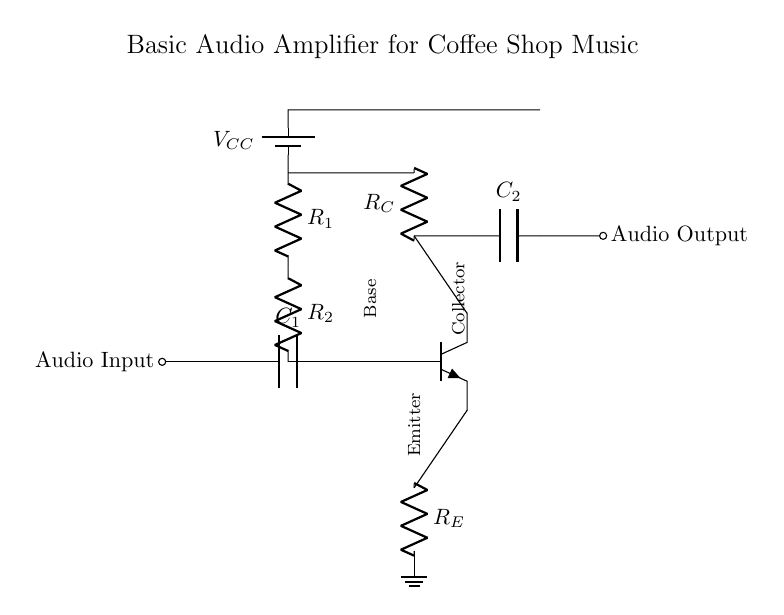What component is used to block DC voltage? The capacitor labeled C1 is used to block DC voltage while allowing AC signals to pass through. Capacitors in audio circuits perform this function to prevent any unwanted DC offset from reaching the amplifier.
Answer: C1 What is the role of resistor R_E? Resistor R_E, or the emitter resistor, provides stability for the transistor's operation by setting the emitter current. This helps improve linearity and temperature stability, thus ensuring consistent amplification across variable inputs.
Answer: R_E How many resistors are present in this circuit? There are three resistors labeled R1, R2, and R_E. These resistors play crucial roles in biasing the transistor and controlling the input and output currents in the amplifier circuit.
Answer: 3 What is the function of capacitor C2? Capacitor C2 is used to couple the amplified audio signal to the output. It allows AC signals to pass while preventing any DC component from affecting the next stage, ensuring clean audio output.
Answer: C2 What type of transistor is used in this circuit? The circuit diagram shows an NPN transistor which is commonly used in audio amplifiers to provide gain and amplifies the input signal. NPN types are preferred for audio applications due to their performance characteristics.
Answer: NPN What does V_CC represent in this circuit? V_CC represents the supply voltage provided to the amplifier; it feeds power to the circuit to allow the transistor and other components to function correctly, ensuring the amplifier can properly amplify audio signals.
Answer: V_CC How does the input audio signal connect to the amplifier? The input audio signal connects to the amplifier through a coupling capacitor (C1), which allows the AC audio signals to enter the circuit while blocking any DC components that might interfere with the amplification process.
Answer: C1 